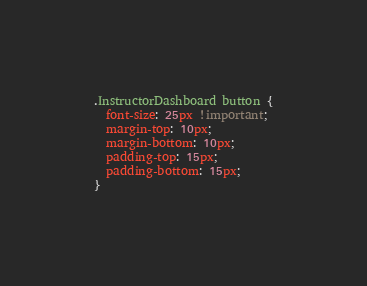Convert code to text. <code><loc_0><loc_0><loc_500><loc_500><_CSS_>.InstructorDashboard button {
  font-size: 25px !important;
  margin-top: 10px;
  margin-bottom: 10px;
  padding-top: 15px;
  padding-bottom: 15px;
}
</code> 